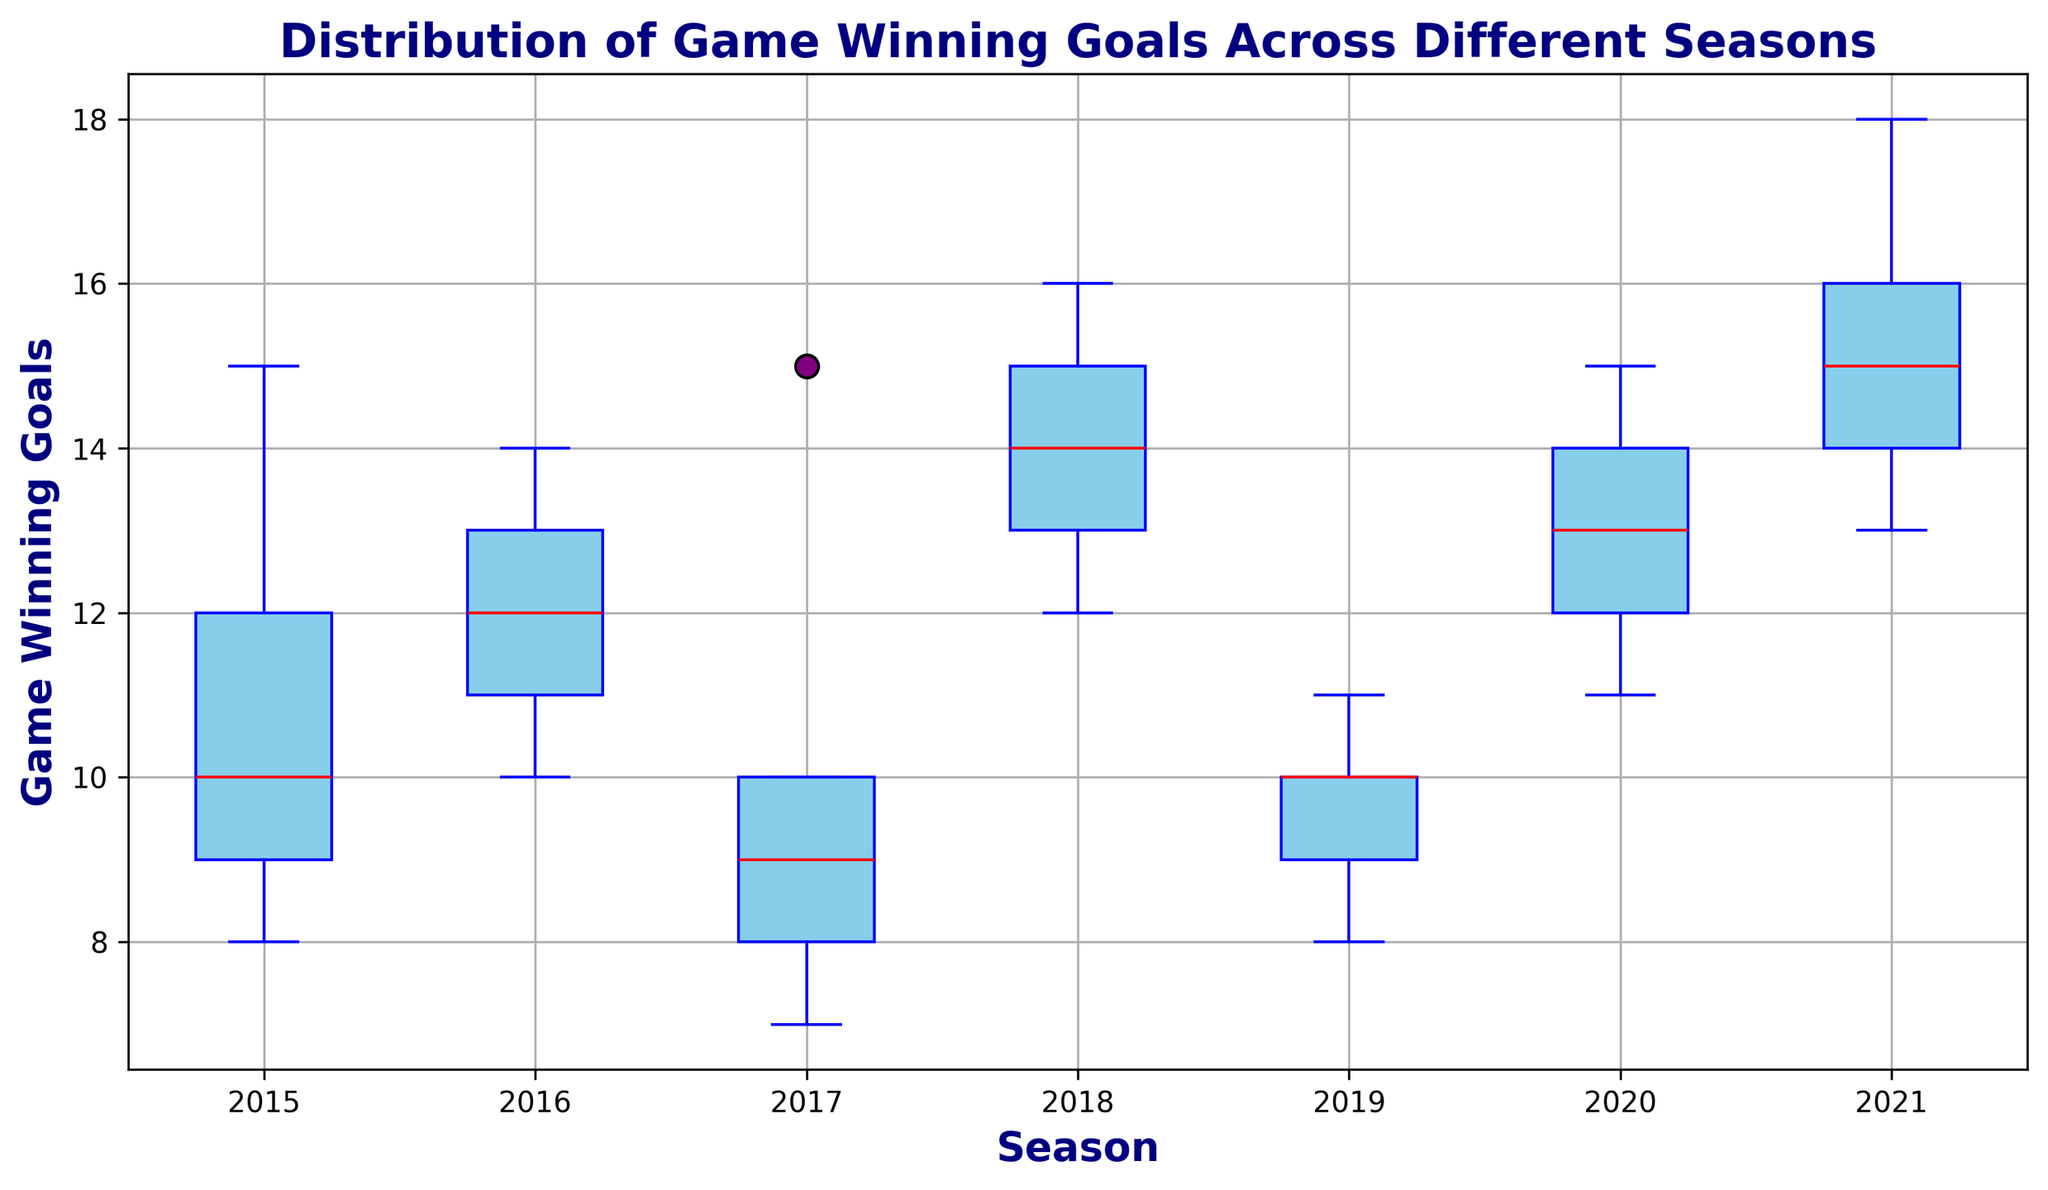Which season had the highest median of game-winning goals? To determine the season with the highest median, look at the central red line of each box plot. The season with the highest median value will have the red line at the highest vertical position.
Answer: 2021 In which seasons is the range between the maximum and minimum goals the largest? The range is the distance between the highest whisker and the lowest whisker of each box plot. Identify the season where this distance is the greatest.
Answer: 2015, 2021 How does the interquartile range (IQR) of 2017 compare to that of 2020? The IQR is represented by the height of the box. Compare the height of the box for 2017 and 2020 by looking at the distance between the bottom and top of each box.
Answer: 2020 is larger Are there any seasons with outliers, and if so, which ones? Outliers are shown as individual points outside the whiskers of the box plot. Look for any such points beyond the whiskers.
Answer: 2017, 2021 What is the median number of game-winning goals in 2018? The median is indicated by the red line within the box plot for the 2018 season. Read off the value at this line.
Answer: 14 Which season had the smallest range of game-winning goals? The range is the distance between the highest and lowest whiskers. The season with the shortest distance between these points has the smallest range.
Answer: 2019 Is there any season in which players scored more consistently (i.e., less spread in the data)? Consistency in scoring corresponds to a smaller IQR or distance between whiskers. Identify the season with the smallest IQR or overall range.
Answer: 2019 What visual feature indicates the maximum game-winning goals in 2021? The maximum value is shown as the top endpoint of the upper whisker in the 2021 box plot. Observe where this endpoint is.
Answer: Top endpoint of the upper whisker 